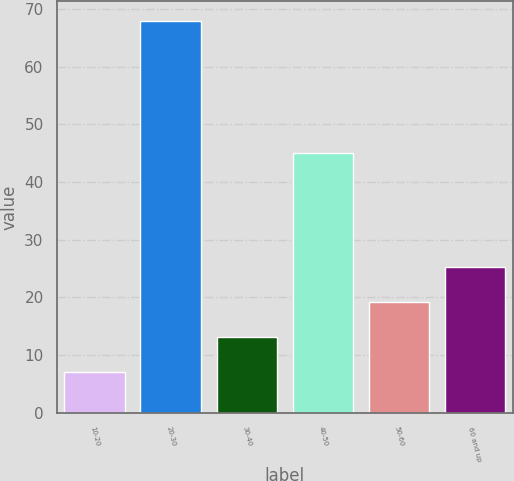Convert chart. <chart><loc_0><loc_0><loc_500><loc_500><bar_chart><fcel>10-20<fcel>20-30<fcel>30-40<fcel>40-50<fcel>50-60<fcel>60 and up<nl><fcel>7<fcel>68<fcel>13.1<fcel>45<fcel>19.2<fcel>25.3<nl></chart> 